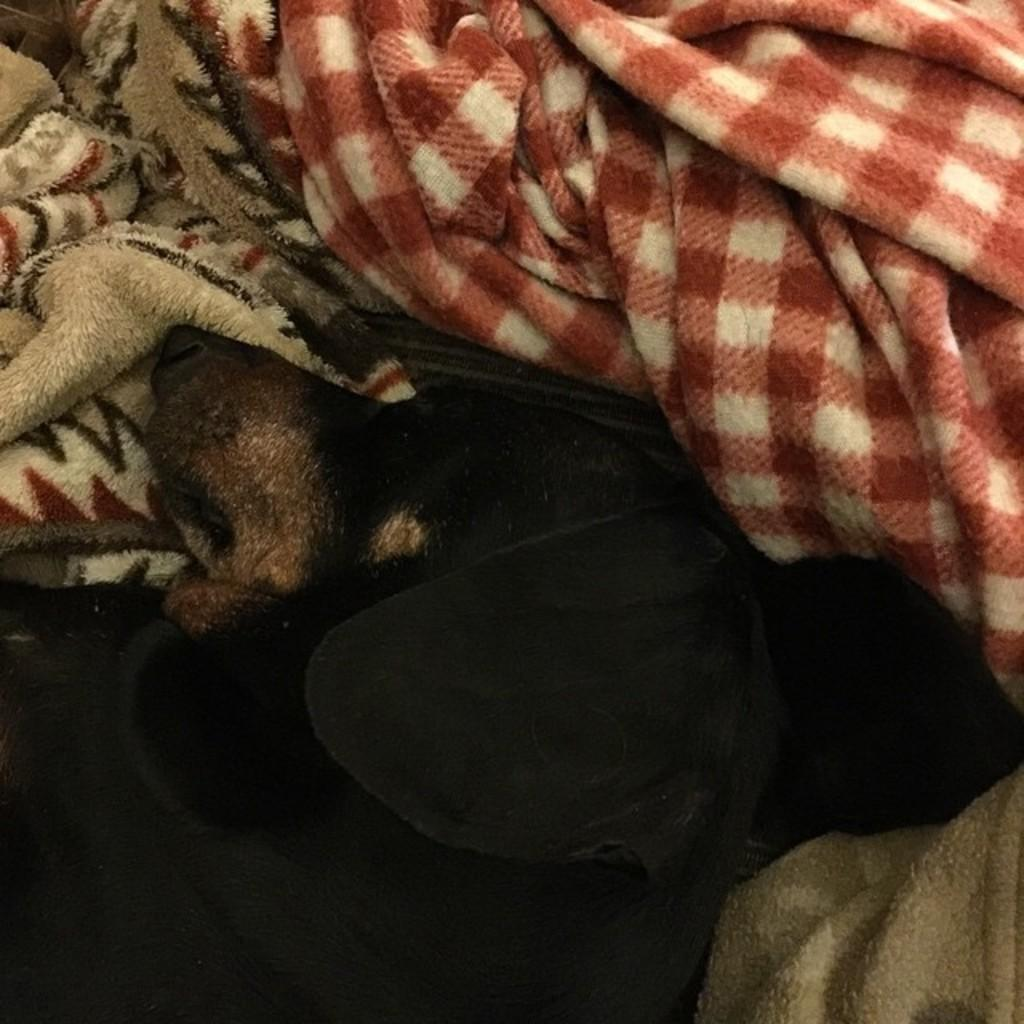What animal can be seen in the image? There is a dog lying down in the image. What is the position of the dog in the image? The dog is lying down in the image. What else is present near the dog in the image? There are clothes beside the dog in the image. What type of sheep can be seen driving a car in the image? There is no sheep or car present in the image; it features a dog lying down and clothes beside it. 